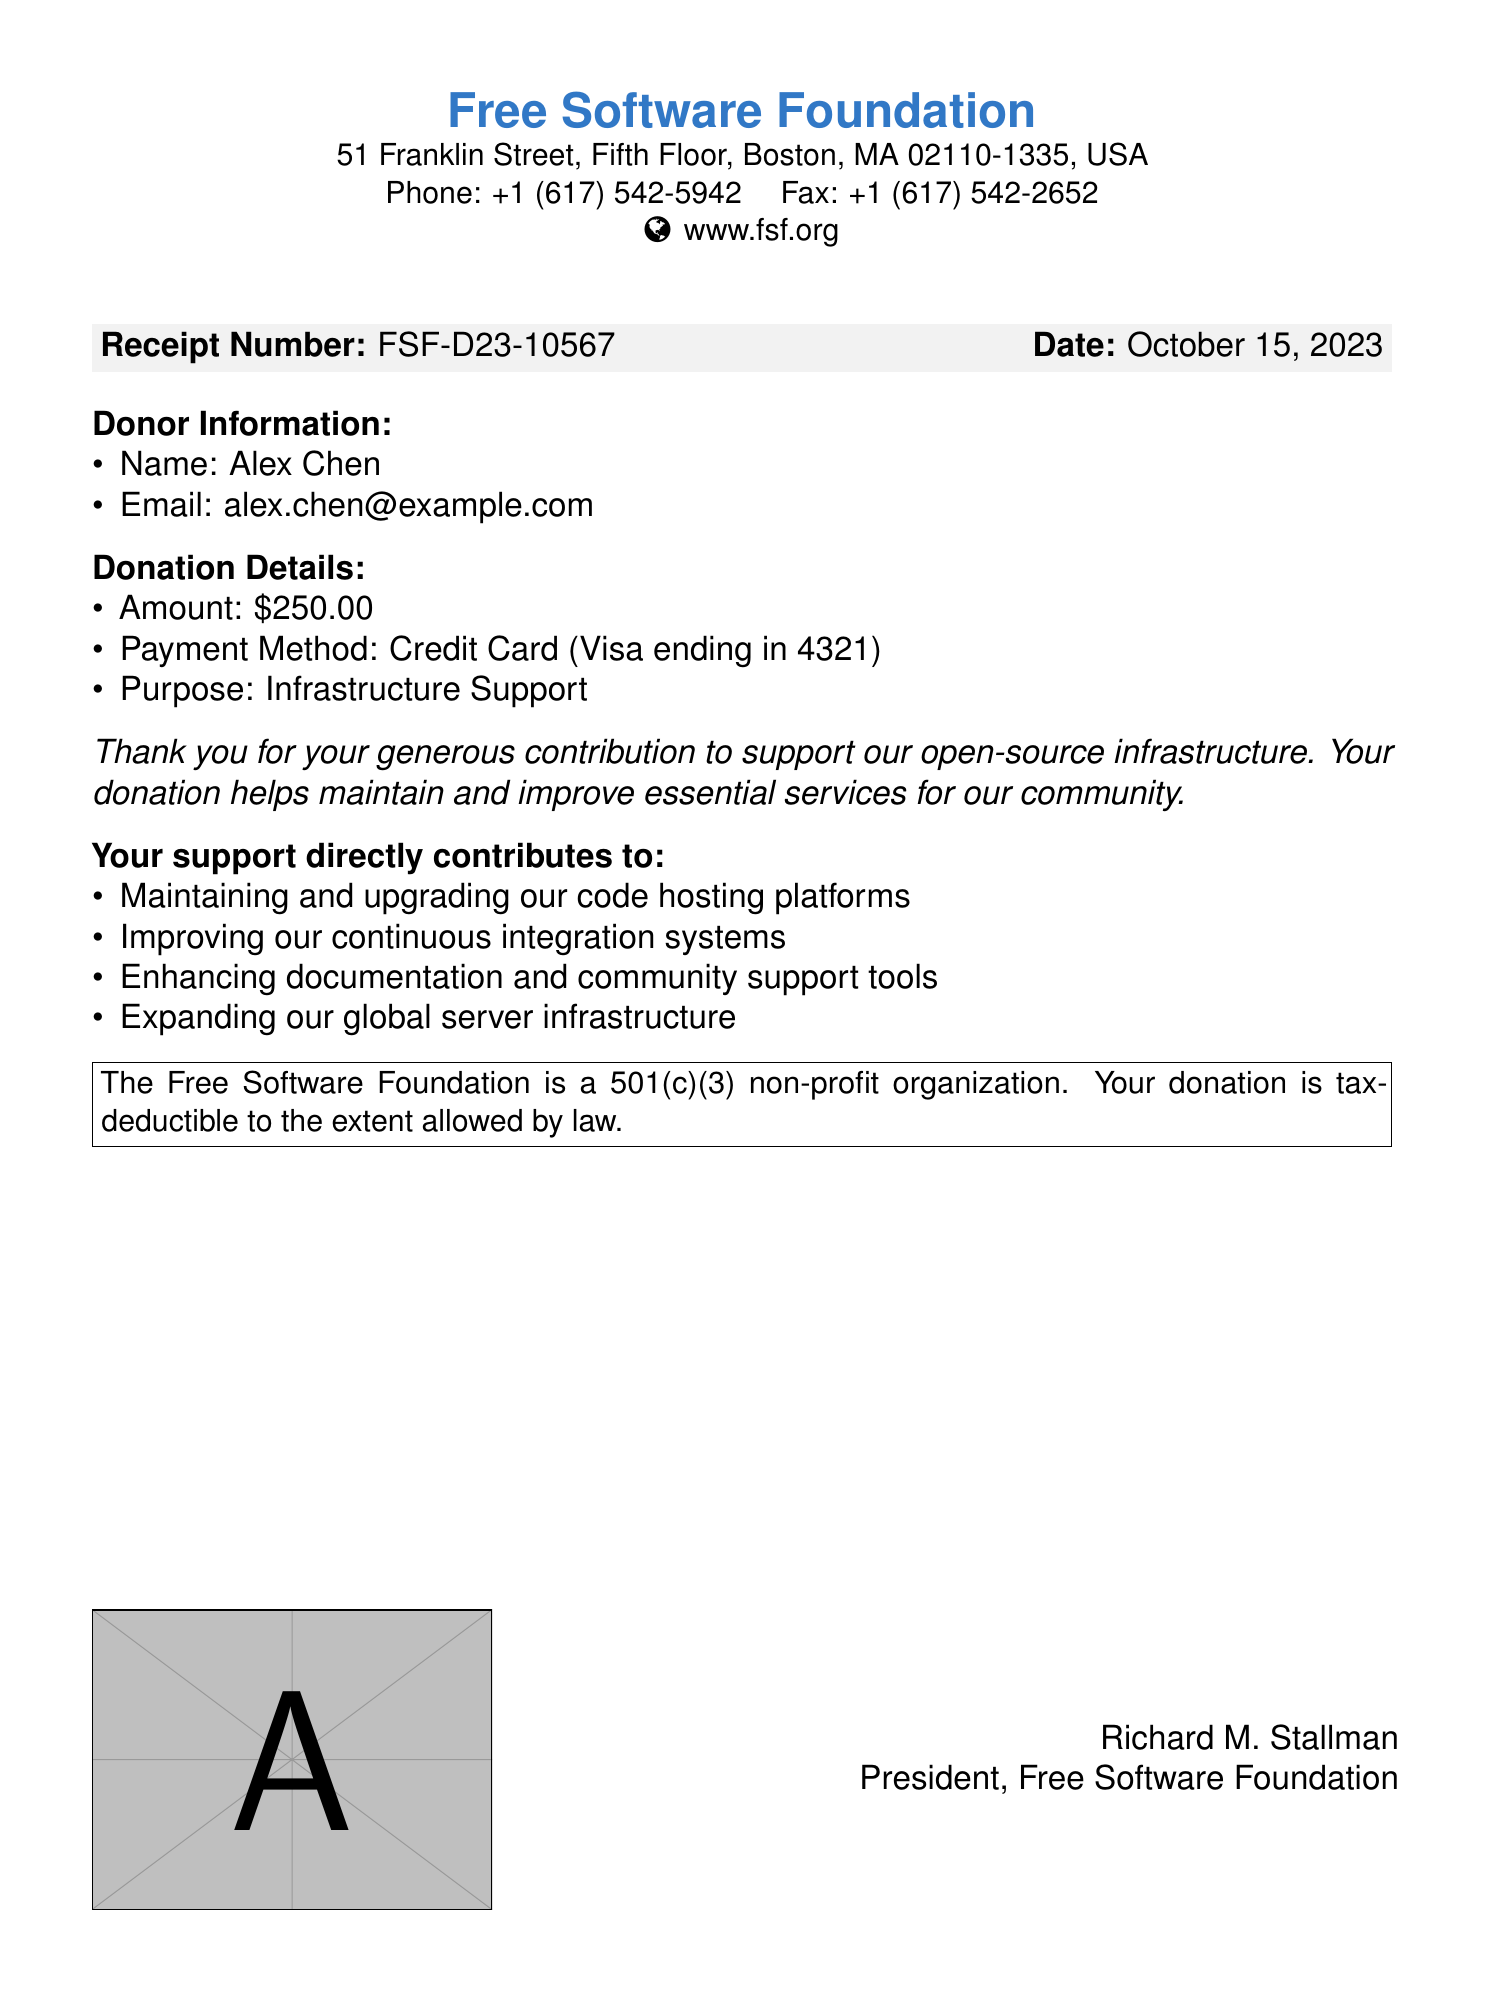What is the receipt number? The receipt number is explicitly stated in the document, identifying the specific transaction.
Answer: FSF-D23-10567 Who is the donor? The document lists the donor's name, which is essential for personal identification.
Answer: Alex Chen What is the donation amount? The donation amount is clearly stated and shows the financial contribution made.
Answer: $250.00 What is the payment method? The document specifies how the donation was made, which includes the type of card and its last digits.
Answer: Credit Card (Visa ending in 4321) What is the date of the donation? The date refers to when the donation was processed, which is significant for record-keeping.
Answer: October 15, 2023 What purpose does the donation support? The document mentions the specific cause for which the donation was intended, indicating its importance.
Answer: Infrastructure Support Who is the president of the Free Software Foundation? The document includes the name of the person leading the organization responsible for the receipt.
Answer: Richard M. Stallman What kind of organization is the Free Software Foundation? The document classifies the type of organization, which is important for understanding its operational framework.
Answer: 501(c)(3) non-profit 